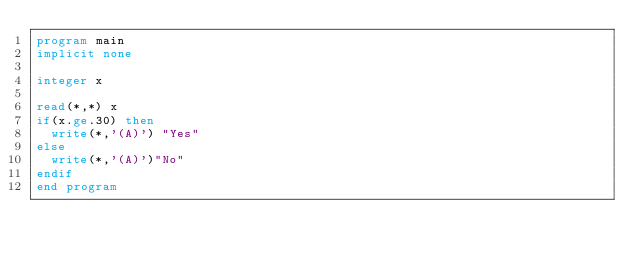<code> <loc_0><loc_0><loc_500><loc_500><_FORTRAN_>program main
implicit none

integer x

read(*,*) x
if(x.ge.30) then
  write(*,'(A)') "Yes"
else
  write(*,'(A)')"No"
endif
end program
</code> 